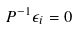<formula> <loc_0><loc_0><loc_500><loc_500>P ^ { - 1 } \epsilon _ { i } = 0</formula> 